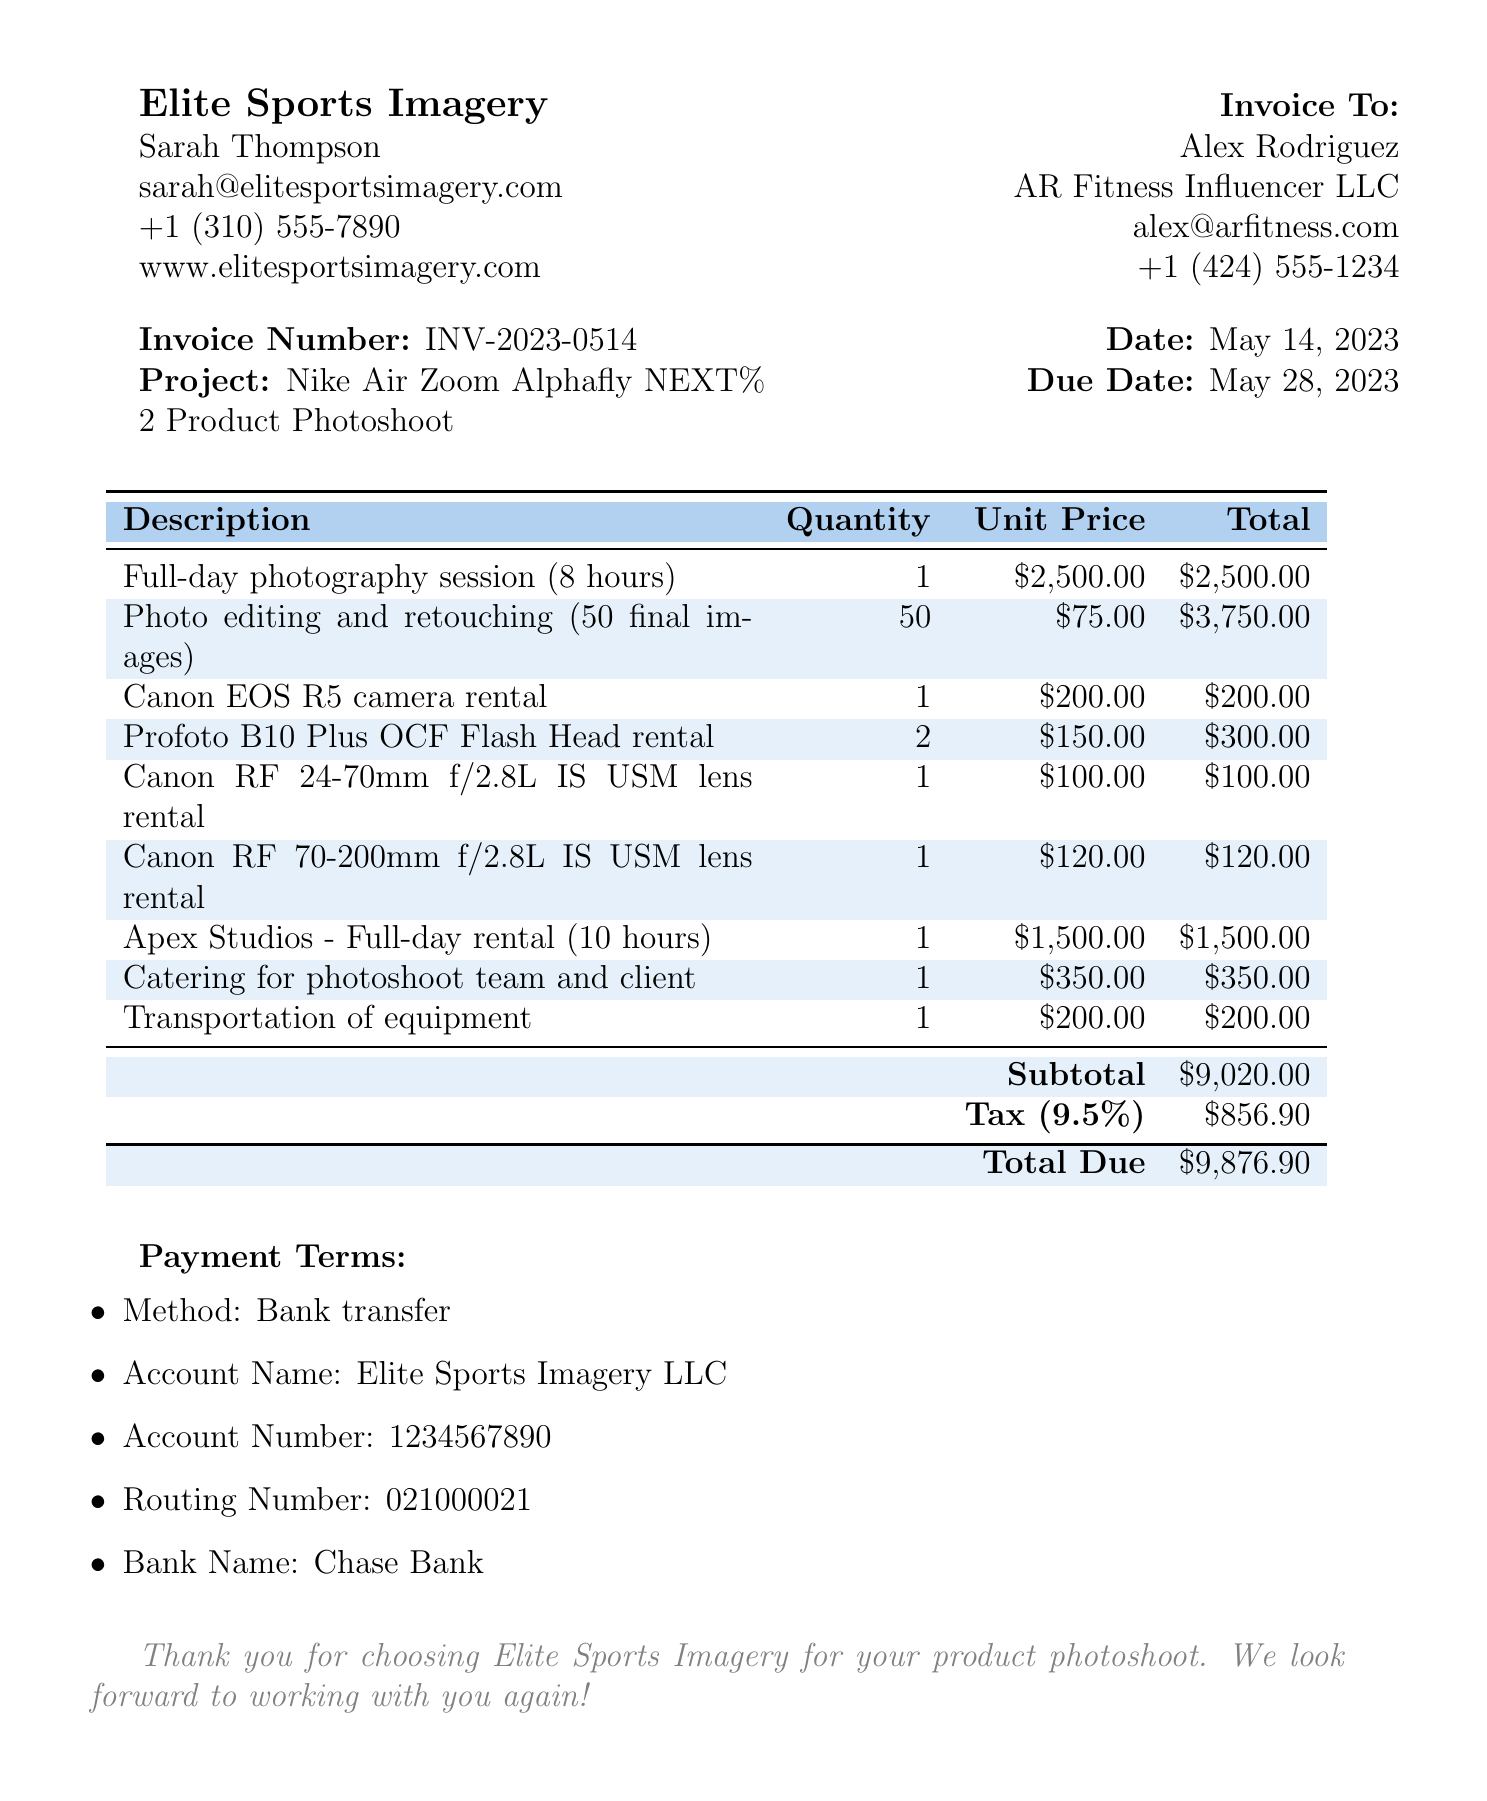What is the photographer's name? The document states the photographer's name is Sarah Thompson, which is included in the contact details.
Answer: Sarah Thompson What is the total due amount? The total due amount can be found in the summary section of the invoice, which calculates all fees and taxes.
Answer: $9,876.90 What is the project name? The project name for the photoshoot is listed in the invoice details section.
Answer: Nike Air Zoom Alphafly NEXT% 2 Product Photoshoot How many final images were edited and retouched? The document mentions that 50 final images were edited and retouched as part of the services provided.
Answer: 50 What is the rental price for the Apex Studios? The invoice states the rental price for Apex Studios in the studio rental section.
Answer: $1,500.00 What is the due date for this invoice? The due date is clearly mentioned in the invoice details section.
Answer: May 28, 2023 How much was spent on catering for the photoshoot? The document specifies the expense for catering, which is represented as an additional cost.
Answer: $350 What method of payment is indicated? The payment terms section specifies the method of payment for the invoice.
Answer: Bank transfer What is the tax rate applied? The tax rate is mentioned in the summary section of the document as a percentage.
Answer: 9.5% 